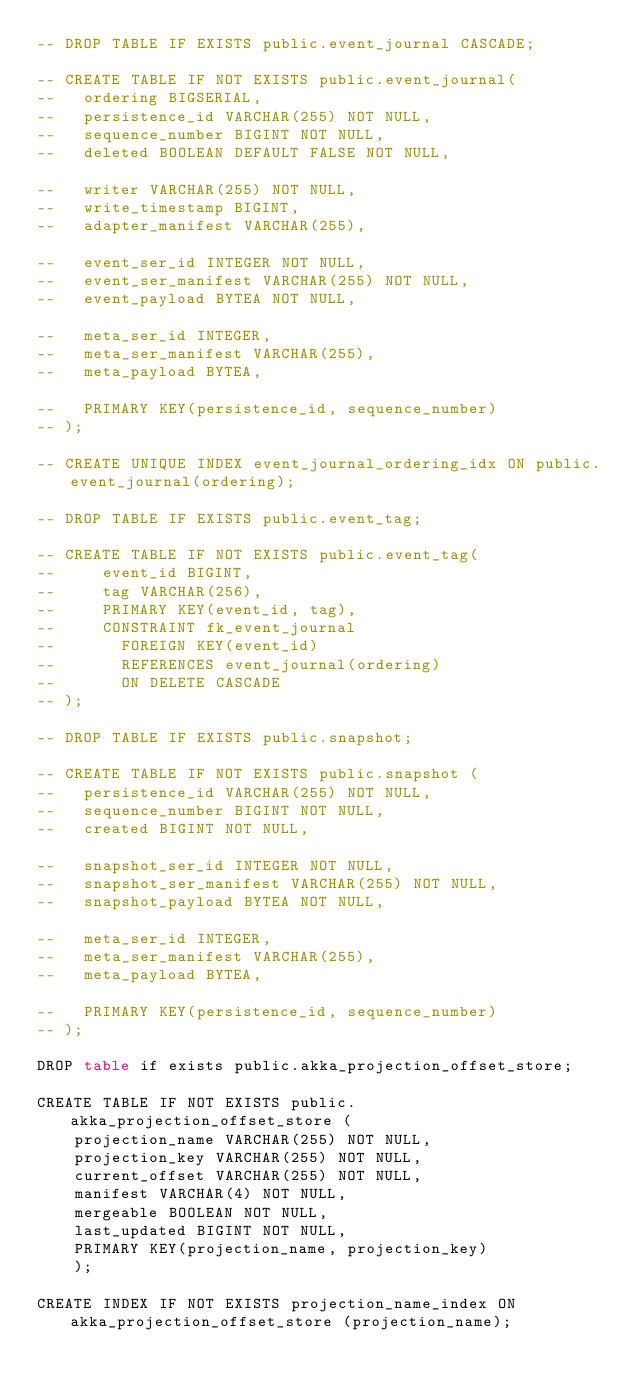Convert code to text. <code><loc_0><loc_0><loc_500><loc_500><_SQL_>-- DROP TABLE IF EXISTS public.event_journal CASCADE;

-- CREATE TABLE IF NOT EXISTS public.event_journal(
--   ordering BIGSERIAL,
--   persistence_id VARCHAR(255) NOT NULL,
--   sequence_number BIGINT NOT NULL,
--   deleted BOOLEAN DEFAULT FALSE NOT NULL,

--   writer VARCHAR(255) NOT NULL,
--   write_timestamp BIGINT,
--   adapter_manifest VARCHAR(255),

--   event_ser_id INTEGER NOT NULL,
--   event_ser_manifest VARCHAR(255) NOT NULL,
--   event_payload BYTEA NOT NULL,

--   meta_ser_id INTEGER,
--   meta_ser_manifest VARCHAR(255),
--   meta_payload BYTEA,

--   PRIMARY KEY(persistence_id, sequence_number)
-- );

-- CREATE UNIQUE INDEX event_journal_ordering_idx ON public.event_journal(ordering);

-- DROP TABLE IF EXISTS public.event_tag;

-- CREATE TABLE IF NOT EXISTS public.event_tag(
--     event_id BIGINT,
--     tag VARCHAR(256),
--     PRIMARY KEY(event_id, tag),
--     CONSTRAINT fk_event_journal
--       FOREIGN KEY(event_id)
--       REFERENCES event_journal(ordering)
--       ON DELETE CASCADE
-- );

-- DROP TABLE IF EXISTS public.snapshot;

-- CREATE TABLE IF NOT EXISTS public.snapshot (
--   persistence_id VARCHAR(255) NOT NULL,
--   sequence_number BIGINT NOT NULL,
--   created BIGINT NOT NULL,

--   snapshot_ser_id INTEGER NOT NULL,
--   snapshot_ser_manifest VARCHAR(255) NOT NULL,
--   snapshot_payload BYTEA NOT NULL,

--   meta_ser_id INTEGER,
--   meta_ser_manifest VARCHAR(255),
--   meta_payload BYTEA,

--   PRIMARY KEY(persistence_id, sequence_number)
-- );

DROP table if exists public.akka_projection_offset_store;

CREATE TABLE IF NOT EXISTS public.akka_projection_offset_store (
    projection_name VARCHAR(255) NOT NULL,
    projection_key VARCHAR(255) NOT NULL,
    current_offset VARCHAR(255) NOT NULL,
    manifest VARCHAR(4) NOT NULL,
    mergeable BOOLEAN NOT NULL,
    last_updated BIGINT NOT NULL,
    PRIMARY KEY(projection_name, projection_key)
    );

CREATE INDEX IF NOT EXISTS projection_name_index ON akka_projection_offset_store (projection_name);</code> 